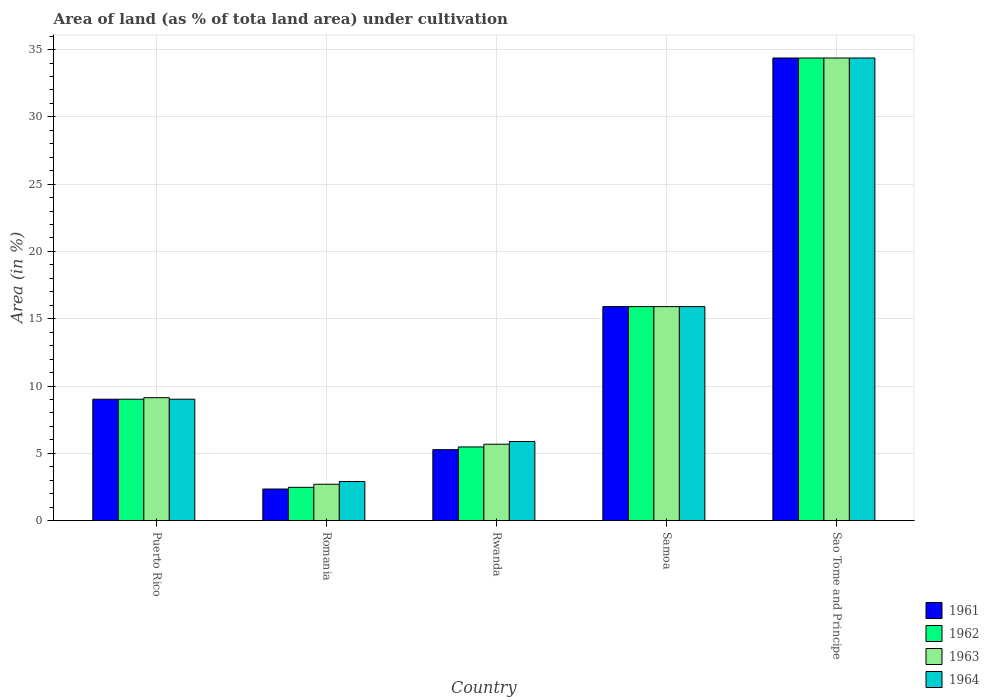How many different coloured bars are there?
Your response must be concise. 4. Are the number of bars per tick equal to the number of legend labels?
Provide a short and direct response. Yes. How many bars are there on the 5th tick from the left?
Make the answer very short. 4. What is the label of the 1st group of bars from the left?
Keep it short and to the point. Puerto Rico. What is the percentage of land under cultivation in 1964 in Puerto Rico?
Your answer should be compact. 9.02. Across all countries, what is the maximum percentage of land under cultivation in 1964?
Offer a terse response. 34.38. Across all countries, what is the minimum percentage of land under cultivation in 1961?
Make the answer very short. 2.34. In which country was the percentage of land under cultivation in 1963 maximum?
Your answer should be very brief. Sao Tome and Principe. In which country was the percentage of land under cultivation in 1963 minimum?
Your answer should be very brief. Romania. What is the total percentage of land under cultivation in 1963 in the graph?
Provide a succinct answer. 67.78. What is the difference between the percentage of land under cultivation in 1964 in Puerto Rico and that in Samoa?
Offer a terse response. -6.88. What is the difference between the percentage of land under cultivation in 1962 in Sao Tome and Principe and the percentage of land under cultivation in 1964 in Romania?
Provide a short and direct response. 31.47. What is the average percentage of land under cultivation in 1963 per country?
Provide a short and direct response. 13.56. What is the difference between the percentage of land under cultivation of/in 1963 and percentage of land under cultivation of/in 1961 in Puerto Rico?
Offer a very short reply. 0.11. What is the ratio of the percentage of land under cultivation in 1962 in Romania to that in Rwanda?
Keep it short and to the point. 0.45. Is the percentage of land under cultivation in 1963 in Romania less than that in Sao Tome and Principe?
Provide a succinct answer. Yes. What is the difference between the highest and the second highest percentage of land under cultivation in 1964?
Your answer should be compact. -25.36. What is the difference between the highest and the lowest percentage of land under cultivation in 1964?
Provide a short and direct response. 31.47. Is it the case that in every country, the sum of the percentage of land under cultivation in 1961 and percentage of land under cultivation in 1962 is greater than the sum of percentage of land under cultivation in 1964 and percentage of land under cultivation in 1963?
Make the answer very short. No. What does the 4th bar from the left in Rwanda represents?
Offer a very short reply. 1964. What does the 3rd bar from the right in Samoa represents?
Make the answer very short. 1962. Are all the bars in the graph horizontal?
Make the answer very short. No. What is the difference between two consecutive major ticks on the Y-axis?
Give a very brief answer. 5. Are the values on the major ticks of Y-axis written in scientific E-notation?
Your answer should be very brief. No. What is the title of the graph?
Offer a terse response. Area of land (as % of tota land area) under cultivation. Does "1994" appear as one of the legend labels in the graph?
Make the answer very short. No. What is the label or title of the Y-axis?
Provide a succinct answer. Area (in %). What is the Area (in %) of 1961 in Puerto Rico?
Keep it short and to the point. 9.02. What is the Area (in %) of 1962 in Puerto Rico?
Your answer should be compact. 9.02. What is the Area (in %) of 1963 in Puerto Rico?
Offer a very short reply. 9.13. What is the Area (in %) in 1964 in Puerto Rico?
Your answer should be very brief. 9.02. What is the Area (in %) in 1961 in Romania?
Ensure brevity in your answer.  2.34. What is the Area (in %) of 1962 in Romania?
Your response must be concise. 2.47. What is the Area (in %) in 1963 in Romania?
Provide a short and direct response. 2.7. What is the Area (in %) in 1964 in Romania?
Give a very brief answer. 2.9. What is the Area (in %) in 1961 in Rwanda?
Provide a short and direct response. 5.27. What is the Area (in %) in 1962 in Rwanda?
Provide a short and direct response. 5.47. What is the Area (in %) of 1963 in Rwanda?
Make the answer very short. 5.67. What is the Area (in %) in 1964 in Rwanda?
Your answer should be very brief. 5.88. What is the Area (in %) of 1961 in Samoa?
Your response must be concise. 15.9. What is the Area (in %) of 1962 in Samoa?
Provide a short and direct response. 15.9. What is the Area (in %) of 1963 in Samoa?
Offer a very short reply. 15.9. What is the Area (in %) of 1964 in Samoa?
Offer a very short reply. 15.9. What is the Area (in %) in 1961 in Sao Tome and Principe?
Offer a very short reply. 34.38. What is the Area (in %) of 1962 in Sao Tome and Principe?
Provide a succinct answer. 34.38. What is the Area (in %) in 1963 in Sao Tome and Principe?
Provide a succinct answer. 34.38. What is the Area (in %) of 1964 in Sao Tome and Principe?
Provide a succinct answer. 34.38. Across all countries, what is the maximum Area (in %) in 1961?
Provide a short and direct response. 34.38. Across all countries, what is the maximum Area (in %) of 1962?
Make the answer very short. 34.38. Across all countries, what is the maximum Area (in %) in 1963?
Your response must be concise. 34.38. Across all countries, what is the maximum Area (in %) of 1964?
Provide a short and direct response. 34.38. Across all countries, what is the minimum Area (in %) in 1961?
Your answer should be compact. 2.34. Across all countries, what is the minimum Area (in %) in 1962?
Offer a very short reply. 2.47. Across all countries, what is the minimum Area (in %) of 1963?
Offer a terse response. 2.7. Across all countries, what is the minimum Area (in %) in 1964?
Your answer should be compact. 2.9. What is the total Area (in %) in 1961 in the graph?
Provide a short and direct response. 66.91. What is the total Area (in %) of 1962 in the graph?
Provide a succinct answer. 67.24. What is the total Area (in %) of 1963 in the graph?
Provide a short and direct response. 67.78. What is the total Area (in %) in 1964 in the graph?
Offer a very short reply. 68.08. What is the difference between the Area (in %) in 1961 in Puerto Rico and that in Romania?
Your response must be concise. 6.67. What is the difference between the Area (in %) in 1962 in Puerto Rico and that in Romania?
Offer a terse response. 6.55. What is the difference between the Area (in %) in 1963 in Puerto Rico and that in Romania?
Your response must be concise. 6.43. What is the difference between the Area (in %) of 1964 in Puerto Rico and that in Romania?
Provide a short and direct response. 6.11. What is the difference between the Area (in %) of 1961 in Puerto Rico and that in Rwanda?
Give a very brief answer. 3.75. What is the difference between the Area (in %) in 1962 in Puerto Rico and that in Rwanda?
Provide a succinct answer. 3.55. What is the difference between the Area (in %) in 1963 in Puerto Rico and that in Rwanda?
Your response must be concise. 3.46. What is the difference between the Area (in %) in 1964 in Puerto Rico and that in Rwanda?
Your answer should be very brief. 3.14. What is the difference between the Area (in %) of 1961 in Puerto Rico and that in Samoa?
Offer a terse response. -6.88. What is the difference between the Area (in %) of 1962 in Puerto Rico and that in Samoa?
Provide a short and direct response. -6.88. What is the difference between the Area (in %) of 1963 in Puerto Rico and that in Samoa?
Offer a terse response. -6.77. What is the difference between the Area (in %) in 1964 in Puerto Rico and that in Samoa?
Provide a succinct answer. -6.88. What is the difference between the Area (in %) in 1961 in Puerto Rico and that in Sao Tome and Principe?
Ensure brevity in your answer.  -25.36. What is the difference between the Area (in %) of 1962 in Puerto Rico and that in Sao Tome and Principe?
Make the answer very short. -25.36. What is the difference between the Area (in %) in 1963 in Puerto Rico and that in Sao Tome and Principe?
Make the answer very short. -25.24. What is the difference between the Area (in %) of 1964 in Puerto Rico and that in Sao Tome and Principe?
Give a very brief answer. -25.36. What is the difference between the Area (in %) in 1961 in Romania and that in Rwanda?
Make the answer very short. -2.93. What is the difference between the Area (in %) of 1962 in Romania and that in Rwanda?
Ensure brevity in your answer.  -3. What is the difference between the Area (in %) in 1963 in Romania and that in Rwanda?
Provide a succinct answer. -2.97. What is the difference between the Area (in %) of 1964 in Romania and that in Rwanda?
Your answer should be compact. -2.97. What is the difference between the Area (in %) in 1961 in Romania and that in Samoa?
Give a very brief answer. -13.56. What is the difference between the Area (in %) of 1962 in Romania and that in Samoa?
Give a very brief answer. -13.43. What is the difference between the Area (in %) of 1963 in Romania and that in Samoa?
Offer a terse response. -13.2. What is the difference between the Area (in %) of 1964 in Romania and that in Samoa?
Offer a very short reply. -13. What is the difference between the Area (in %) in 1961 in Romania and that in Sao Tome and Principe?
Give a very brief answer. -32.03. What is the difference between the Area (in %) of 1962 in Romania and that in Sao Tome and Principe?
Keep it short and to the point. -31.9. What is the difference between the Area (in %) in 1963 in Romania and that in Sao Tome and Principe?
Provide a short and direct response. -31.67. What is the difference between the Area (in %) in 1964 in Romania and that in Sao Tome and Principe?
Give a very brief answer. -31.47. What is the difference between the Area (in %) in 1961 in Rwanda and that in Samoa?
Offer a terse response. -10.63. What is the difference between the Area (in %) of 1962 in Rwanda and that in Samoa?
Provide a short and direct response. -10.43. What is the difference between the Area (in %) of 1963 in Rwanda and that in Samoa?
Give a very brief answer. -10.23. What is the difference between the Area (in %) of 1964 in Rwanda and that in Samoa?
Provide a short and direct response. -10.02. What is the difference between the Area (in %) in 1961 in Rwanda and that in Sao Tome and Principe?
Make the answer very short. -29.11. What is the difference between the Area (in %) in 1962 in Rwanda and that in Sao Tome and Principe?
Make the answer very short. -28.9. What is the difference between the Area (in %) of 1963 in Rwanda and that in Sao Tome and Principe?
Offer a terse response. -28.7. What is the difference between the Area (in %) of 1964 in Rwanda and that in Sao Tome and Principe?
Keep it short and to the point. -28.5. What is the difference between the Area (in %) of 1961 in Samoa and that in Sao Tome and Principe?
Offer a terse response. -18.47. What is the difference between the Area (in %) of 1962 in Samoa and that in Sao Tome and Principe?
Your response must be concise. -18.47. What is the difference between the Area (in %) of 1963 in Samoa and that in Sao Tome and Principe?
Provide a succinct answer. -18.47. What is the difference between the Area (in %) of 1964 in Samoa and that in Sao Tome and Principe?
Your answer should be compact. -18.47. What is the difference between the Area (in %) in 1961 in Puerto Rico and the Area (in %) in 1962 in Romania?
Your answer should be very brief. 6.55. What is the difference between the Area (in %) in 1961 in Puerto Rico and the Area (in %) in 1963 in Romania?
Ensure brevity in your answer.  6.32. What is the difference between the Area (in %) of 1961 in Puerto Rico and the Area (in %) of 1964 in Romania?
Provide a succinct answer. 6.11. What is the difference between the Area (in %) in 1962 in Puerto Rico and the Area (in %) in 1963 in Romania?
Make the answer very short. 6.32. What is the difference between the Area (in %) in 1962 in Puerto Rico and the Area (in %) in 1964 in Romania?
Provide a succinct answer. 6.11. What is the difference between the Area (in %) in 1963 in Puerto Rico and the Area (in %) in 1964 in Romania?
Provide a succinct answer. 6.23. What is the difference between the Area (in %) of 1961 in Puerto Rico and the Area (in %) of 1962 in Rwanda?
Provide a short and direct response. 3.55. What is the difference between the Area (in %) of 1961 in Puerto Rico and the Area (in %) of 1963 in Rwanda?
Provide a succinct answer. 3.34. What is the difference between the Area (in %) in 1961 in Puerto Rico and the Area (in %) in 1964 in Rwanda?
Provide a short and direct response. 3.14. What is the difference between the Area (in %) of 1962 in Puerto Rico and the Area (in %) of 1963 in Rwanda?
Your answer should be very brief. 3.34. What is the difference between the Area (in %) of 1962 in Puerto Rico and the Area (in %) of 1964 in Rwanda?
Make the answer very short. 3.14. What is the difference between the Area (in %) of 1963 in Puerto Rico and the Area (in %) of 1964 in Rwanda?
Provide a short and direct response. 3.25. What is the difference between the Area (in %) of 1961 in Puerto Rico and the Area (in %) of 1962 in Samoa?
Provide a succinct answer. -6.88. What is the difference between the Area (in %) in 1961 in Puerto Rico and the Area (in %) in 1963 in Samoa?
Give a very brief answer. -6.88. What is the difference between the Area (in %) in 1961 in Puerto Rico and the Area (in %) in 1964 in Samoa?
Offer a terse response. -6.88. What is the difference between the Area (in %) in 1962 in Puerto Rico and the Area (in %) in 1963 in Samoa?
Make the answer very short. -6.88. What is the difference between the Area (in %) in 1962 in Puerto Rico and the Area (in %) in 1964 in Samoa?
Your response must be concise. -6.88. What is the difference between the Area (in %) of 1963 in Puerto Rico and the Area (in %) of 1964 in Samoa?
Make the answer very short. -6.77. What is the difference between the Area (in %) in 1961 in Puerto Rico and the Area (in %) in 1962 in Sao Tome and Principe?
Provide a short and direct response. -25.36. What is the difference between the Area (in %) in 1961 in Puerto Rico and the Area (in %) in 1963 in Sao Tome and Principe?
Provide a short and direct response. -25.36. What is the difference between the Area (in %) in 1961 in Puerto Rico and the Area (in %) in 1964 in Sao Tome and Principe?
Provide a short and direct response. -25.36. What is the difference between the Area (in %) of 1962 in Puerto Rico and the Area (in %) of 1963 in Sao Tome and Principe?
Provide a short and direct response. -25.36. What is the difference between the Area (in %) in 1962 in Puerto Rico and the Area (in %) in 1964 in Sao Tome and Principe?
Give a very brief answer. -25.36. What is the difference between the Area (in %) of 1963 in Puerto Rico and the Area (in %) of 1964 in Sao Tome and Principe?
Give a very brief answer. -25.24. What is the difference between the Area (in %) in 1961 in Romania and the Area (in %) in 1962 in Rwanda?
Offer a very short reply. -3.13. What is the difference between the Area (in %) of 1961 in Romania and the Area (in %) of 1963 in Rwanda?
Provide a short and direct response. -3.33. What is the difference between the Area (in %) in 1961 in Romania and the Area (in %) in 1964 in Rwanda?
Your answer should be very brief. -3.53. What is the difference between the Area (in %) in 1962 in Romania and the Area (in %) in 1963 in Rwanda?
Ensure brevity in your answer.  -3.2. What is the difference between the Area (in %) in 1962 in Romania and the Area (in %) in 1964 in Rwanda?
Your answer should be compact. -3.41. What is the difference between the Area (in %) of 1963 in Romania and the Area (in %) of 1964 in Rwanda?
Offer a terse response. -3.18. What is the difference between the Area (in %) in 1961 in Romania and the Area (in %) in 1962 in Samoa?
Provide a short and direct response. -13.56. What is the difference between the Area (in %) of 1961 in Romania and the Area (in %) of 1963 in Samoa?
Provide a succinct answer. -13.56. What is the difference between the Area (in %) in 1961 in Romania and the Area (in %) in 1964 in Samoa?
Provide a short and direct response. -13.56. What is the difference between the Area (in %) of 1962 in Romania and the Area (in %) of 1963 in Samoa?
Offer a very short reply. -13.43. What is the difference between the Area (in %) in 1962 in Romania and the Area (in %) in 1964 in Samoa?
Offer a very short reply. -13.43. What is the difference between the Area (in %) in 1963 in Romania and the Area (in %) in 1964 in Samoa?
Keep it short and to the point. -13.2. What is the difference between the Area (in %) of 1961 in Romania and the Area (in %) of 1962 in Sao Tome and Principe?
Make the answer very short. -32.03. What is the difference between the Area (in %) in 1961 in Romania and the Area (in %) in 1963 in Sao Tome and Principe?
Your answer should be compact. -32.03. What is the difference between the Area (in %) in 1961 in Romania and the Area (in %) in 1964 in Sao Tome and Principe?
Your response must be concise. -32.03. What is the difference between the Area (in %) in 1962 in Romania and the Area (in %) in 1963 in Sao Tome and Principe?
Provide a succinct answer. -31.9. What is the difference between the Area (in %) in 1962 in Romania and the Area (in %) in 1964 in Sao Tome and Principe?
Offer a very short reply. -31.9. What is the difference between the Area (in %) of 1963 in Romania and the Area (in %) of 1964 in Sao Tome and Principe?
Offer a very short reply. -31.67. What is the difference between the Area (in %) of 1961 in Rwanda and the Area (in %) of 1962 in Samoa?
Your response must be concise. -10.63. What is the difference between the Area (in %) of 1961 in Rwanda and the Area (in %) of 1963 in Samoa?
Provide a succinct answer. -10.63. What is the difference between the Area (in %) in 1961 in Rwanda and the Area (in %) in 1964 in Samoa?
Ensure brevity in your answer.  -10.63. What is the difference between the Area (in %) of 1962 in Rwanda and the Area (in %) of 1963 in Samoa?
Provide a succinct answer. -10.43. What is the difference between the Area (in %) in 1962 in Rwanda and the Area (in %) in 1964 in Samoa?
Offer a terse response. -10.43. What is the difference between the Area (in %) in 1963 in Rwanda and the Area (in %) in 1964 in Samoa?
Make the answer very short. -10.23. What is the difference between the Area (in %) of 1961 in Rwanda and the Area (in %) of 1962 in Sao Tome and Principe?
Your answer should be very brief. -29.11. What is the difference between the Area (in %) of 1961 in Rwanda and the Area (in %) of 1963 in Sao Tome and Principe?
Provide a short and direct response. -29.11. What is the difference between the Area (in %) of 1961 in Rwanda and the Area (in %) of 1964 in Sao Tome and Principe?
Give a very brief answer. -29.11. What is the difference between the Area (in %) in 1962 in Rwanda and the Area (in %) in 1963 in Sao Tome and Principe?
Give a very brief answer. -28.9. What is the difference between the Area (in %) in 1962 in Rwanda and the Area (in %) in 1964 in Sao Tome and Principe?
Your response must be concise. -28.9. What is the difference between the Area (in %) in 1963 in Rwanda and the Area (in %) in 1964 in Sao Tome and Principe?
Provide a succinct answer. -28.7. What is the difference between the Area (in %) of 1961 in Samoa and the Area (in %) of 1962 in Sao Tome and Principe?
Offer a very short reply. -18.47. What is the difference between the Area (in %) in 1961 in Samoa and the Area (in %) in 1963 in Sao Tome and Principe?
Keep it short and to the point. -18.47. What is the difference between the Area (in %) of 1961 in Samoa and the Area (in %) of 1964 in Sao Tome and Principe?
Give a very brief answer. -18.47. What is the difference between the Area (in %) of 1962 in Samoa and the Area (in %) of 1963 in Sao Tome and Principe?
Ensure brevity in your answer.  -18.47. What is the difference between the Area (in %) in 1962 in Samoa and the Area (in %) in 1964 in Sao Tome and Principe?
Offer a very short reply. -18.47. What is the difference between the Area (in %) in 1963 in Samoa and the Area (in %) in 1964 in Sao Tome and Principe?
Provide a short and direct response. -18.47. What is the average Area (in %) in 1961 per country?
Keep it short and to the point. 13.38. What is the average Area (in %) of 1962 per country?
Give a very brief answer. 13.45. What is the average Area (in %) of 1963 per country?
Offer a terse response. 13.56. What is the average Area (in %) in 1964 per country?
Provide a succinct answer. 13.62. What is the difference between the Area (in %) in 1961 and Area (in %) in 1962 in Puerto Rico?
Provide a short and direct response. 0. What is the difference between the Area (in %) of 1961 and Area (in %) of 1963 in Puerto Rico?
Give a very brief answer. -0.11. What is the difference between the Area (in %) in 1962 and Area (in %) in 1963 in Puerto Rico?
Make the answer very short. -0.11. What is the difference between the Area (in %) in 1963 and Area (in %) in 1964 in Puerto Rico?
Give a very brief answer. 0.11. What is the difference between the Area (in %) in 1961 and Area (in %) in 1962 in Romania?
Offer a very short reply. -0.13. What is the difference between the Area (in %) in 1961 and Area (in %) in 1963 in Romania?
Your answer should be very brief. -0.36. What is the difference between the Area (in %) in 1961 and Area (in %) in 1964 in Romania?
Your answer should be very brief. -0.56. What is the difference between the Area (in %) in 1962 and Area (in %) in 1963 in Romania?
Your answer should be very brief. -0.23. What is the difference between the Area (in %) in 1962 and Area (in %) in 1964 in Romania?
Provide a short and direct response. -0.43. What is the difference between the Area (in %) of 1963 and Area (in %) of 1964 in Romania?
Make the answer very short. -0.2. What is the difference between the Area (in %) of 1961 and Area (in %) of 1962 in Rwanda?
Provide a succinct answer. -0.2. What is the difference between the Area (in %) in 1961 and Area (in %) in 1963 in Rwanda?
Provide a short and direct response. -0.41. What is the difference between the Area (in %) in 1961 and Area (in %) in 1964 in Rwanda?
Keep it short and to the point. -0.61. What is the difference between the Area (in %) in 1962 and Area (in %) in 1963 in Rwanda?
Offer a terse response. -0.2. What is the difference between the Area (in %) of 1962 and Area (in %) of 1964 in Rwanda?
Offer a terse response. -0.41. What is the difference between the Area (in %) in 1963 and Area (in %) in 1964 in Rwanda?
Your response must be concise. -0.2. What is the difference between the Area (in %) of 1962 and Area (in %) of 1964 in Samoa?
Provide a succinct answer. 0. What is the difference between the Area (in %) in 1963 and Area (in %) in 1964 in Samoa?
Keep it short and to the point. 0. What is the difference between the Area (in %) in 1961 and Area (in %) in 1964 in Sao Tome and Principe?
Offer a terse response. 0. What is the ratio of the Area (in %) in 1961 in Puerto Rico to that in Romania?
Offer a very short reply. 3.85. What is the ratio of the Area (in %) in 1962 in Puerto Rico to that in Romania?
Offer a very short reply. 3.65. What is the ratio of the Area (in %) in 1963 in Puerto Rico to that in Romania?
Offer a terse response. 3.38. What is the ratio of the Area (in %) in 1964 in Puerto Rico to that in Romania?
Your answer should be very brief. 3.11. What is the ratio of the Area (in %) of 1961 in Puerto Rico to that in Rwanda?
Provide a succinct answer. 1.71. What is the ratio of the Area (in %) in 1962 in Puerto Rico to that in Rwanda?
Your response must be concise. 1.65. What is the ratio of the Area (in %) of 1963 in Puerto Rico to that in Rwanda?
Offer a terse response. 1.61. What is the ratio of the Area (in %) of 1964 in Puerto Rico to that in Rwanda?
Your response must be concise. 1.53. What is the ratio of the Area (in %) in 1961 in Puerto Rico to that in Samoa?
Your response must be concise. 0.57. What is the ratio of the Area (in %) in 1962 in Puerto Rico to that in Samoa?
Offer a very short reply. 0.57. What is the ratio of the Area (in %) of 1963 in Puerto Rico to that in Samoa?
Provide a succinct answer. 0.57. What is the ratio of the Area (in %) of 1964 in Puerto Rico to that in Samoa?
Provide a short and direct response. 0.57. What is the ratio of the Area (in %) of 1961 in Puerto Rico to that in Sao Tome and Principe?
Provide a short and direct response. 0.26. What is the ratio of the Area (in %) of 1962 in Puerto Rico to that in Sao Tome and Principe?
Keep it short and to the point. 0.26. What is the ratio of the Area (in %) in 1963 in Puerto Rico to that in Sao Tome and Principe?
Your answer should be compact. 0.27. What is the ratio of the Area (in %) in 1964 in Puerto Rico to that in Sao Tome and Principe?
Your answer should be very brief. 0.26. What is the ratio of the Area (in %) of 1961 in Romania to that in Rwanda?
Keep it short and to the point. 0.44. What is the ratio of the Area (in %) of 1962 in Romania to that in Rwanda?
Offer a terse response. 0.45. What is the ratio of the Area (in %) of 1963 in Romania to that in Rwanda?
Provide a succinct answer. 0.48. What is the ratio of the Area (in %) in 1964 in Romania to that in Rwanda?
Make the answer very short. 0.49. What is the ratio of the Area (in %) of 1961 in Romania to that in Samoa?
Your answer should be very brief. 0.15. What is the ratio of the Area (in %) in 1962 in Romania to that in Samoa?
Give a very brief answer. 0.16. What is the ratio of the Area (in %) in 1963 in Romania to that in Samoa?
Make the answer very short. 0.17. What is the ratio of the Area (in %) of 1964 in Romania to that in Samoa?
Provide a short and direct response. 0.18. What is the ratio of the Area (in %) of 1961 in Romania to that in Sao Tome and Principe?
Offer a terse response. 0.07. What is the ratio of the Area (in %) of 1962 in Romania to that in Sao Tome and Principe?
Give a very brief answer. 0.07. What is the ratio of the Area (in %) in 1963 in Romania to that in Sao Tome and Principe?
Provide a short and direct response. 0.08. What is the ratio of the Area (in %) of 1964 in Romania to that in Sao Tome and Principe?
Offer a terse response. 0.08. What is the ratio of the Area (in %) of 1961 in Rwanda to that in Samoa?
Provide a short and direct response. 0.33. What is the ratio of the Area (in %) in 1962 in Rwanda to that in Samoa?
Give a very brief answer. 0.34. What is the ratio of the Area (in %) in 1963 in Rwanda to that in Samoa?
Give a very brief answer. 0.36. What is the ratio of the Area (in %) in 1964 in Rwanda to that in Samoa?
Provide a succinct answer. 0.37. What is the ratio of the Area (in %) in 1961 in Rwanda to that in Sao Tome and Principe?
Ensure brevity in your answer.  0.15. What is the ratio of the Area (in %) in 1962 in Rwanda to that in Sao Tome and Principe?
Ensure brevity in your answer.  0.16. What is the ratio of the Area (in %) of 1963 in Rwanda to that in Sao Tome and Principe?
Ensure brevity in your answer.  0.17. What is the ratio of the Area (in %) in 1964 in Rwanda to that in Sao Tome and Principe?
Provide a short and direct response. 0.17. What is the ratio of the Area (in %) of 1961 in Samoa to that in Sao Tome and Principe?
Make the answer very short. 0.46. What is the ratio of the Area (in %) in 1962 in Samoa to that in Sao Tome and Principe?
Make the answer very short. 0.46. What is the ratio of the Area (in %) in 1963 in Samoa to that in Sao Tome and Principe?
Give a very brief answer. 0.46. What is the ratio of the Area (in %) of 1964 in Samoa to that in Sao Tome and Principe?
Give a very brief answer. 0.46. What is the difference between the highest and the second highest Area (in %) in 1961?
Make the answer very short. 18.47. What is the difference between the highest and the second highest Area (in %) in 1962?
Make the answer very short. 18.47. What is the difference between the highest and the second highest Area (in %) of 1963?
Offer a very short reply. 18.47. What is the difference between the highest and the second highest Area (in %) in 1964?
Your answer should be very brief. 18.47. What is the difference between the highest and the lowest Area (in %) of 1961?
Offer a terse response. 32.03. What is the difference between the highest and the lowest Area (in %) in 1962?
Your answer should be compact. 31.9. What is the difference between the highest and the lowest Area (in %) in 1963?
Give a very brief answer. 31.67. What is the difference between the highest and the lowest Area (in %) in 1964?
Your response must be concise. 31.47. 